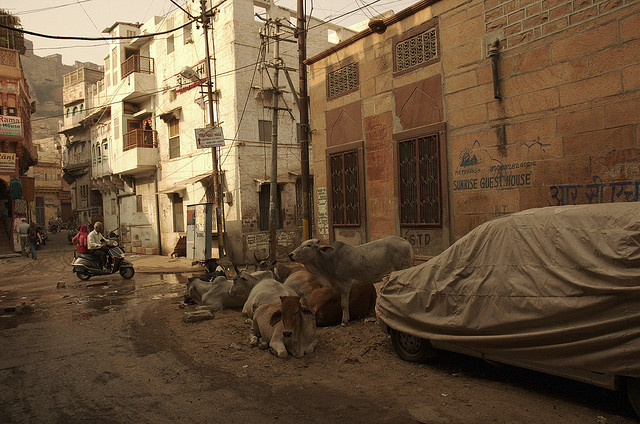Can you describe the significance of cows in this setting? Cows in urban settings like the one depicted are often indicative of regions where they hold cultural and possibly religious significance. In many parts of India, for example, cows are considered sacred and are allowed to roam freely in urban areas. This can also reflect the interaction between rural traditions and urban life, where agricultural practices intersect with city living. 